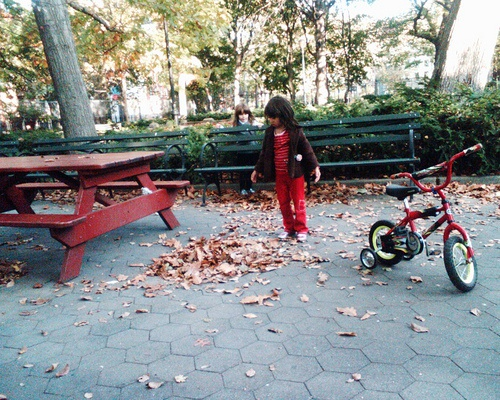Describe the objects in this image and their specific colors. I can see bench in lavender, black, brown, and maroon tones, dining table in lavender, black, brown, and maroon tones, bench in lavender, black, teal, and darkgreen tones, bicycle in lavender, black, darkgray, gray, and lightgray tones, and people in lavender, black, maroon, and brown tones in this image. 